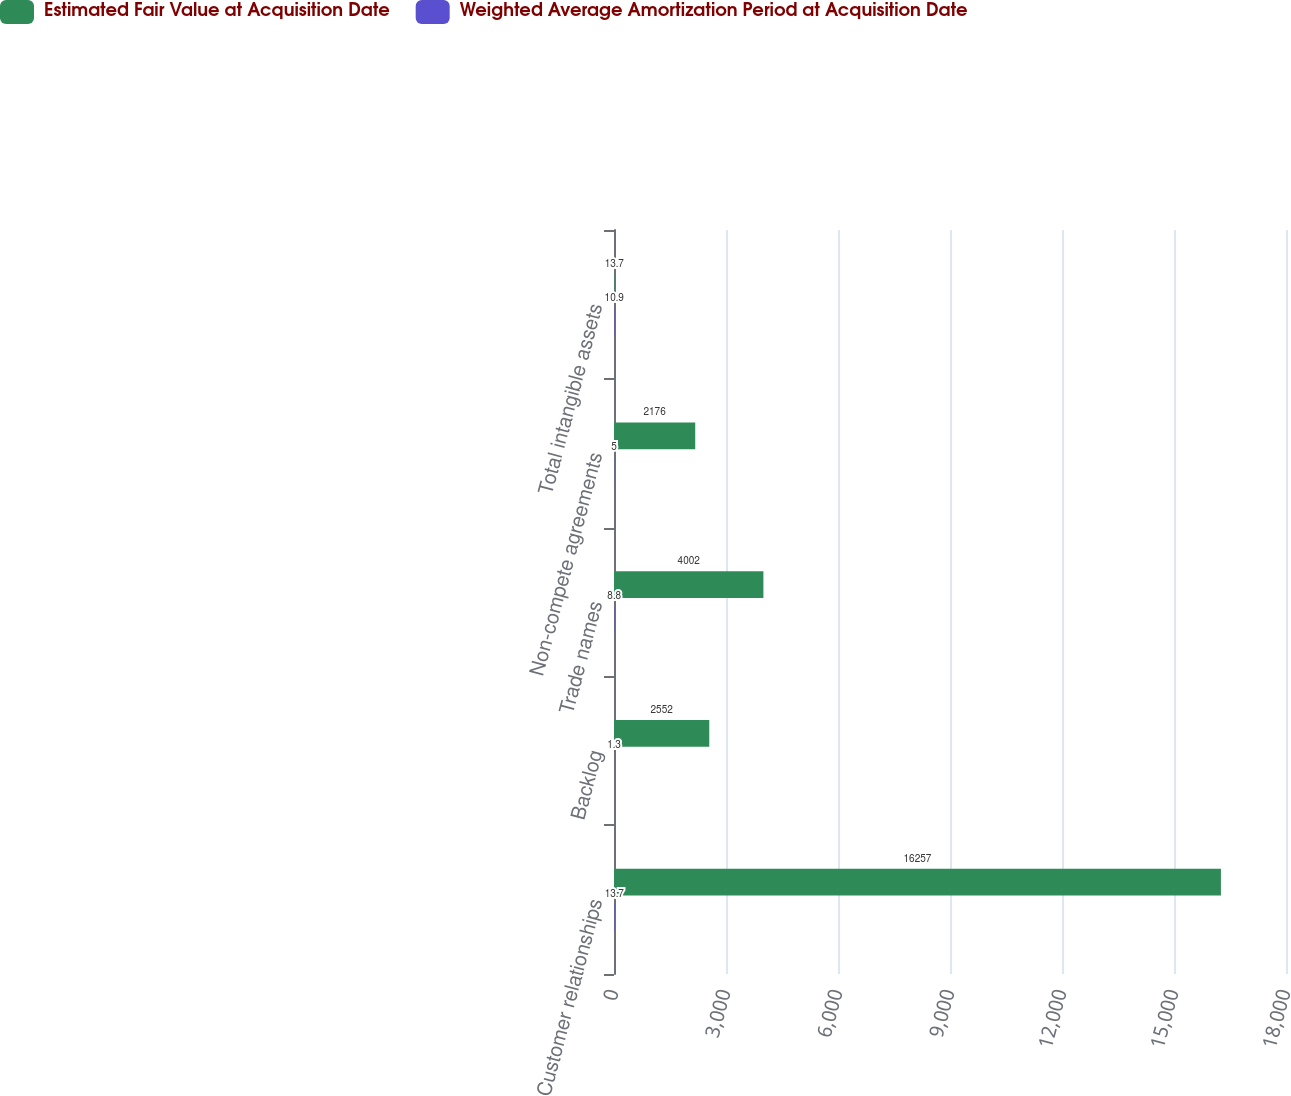<chart> <loc_0><loc_0><loc_500><loc_500><stacked_bar_chart><ecel><fcel>Customer relationships<fcel>Backlog<fcel>Trade names<fcel>Non-compete agreements<fcel>Total intangible assets<nl><fcel>Estimated Fair Value at Acquisition Date<fcel>16257<fcel>2552<fcel>4002<fcel>2176<fcel>13.7<nl><fcel>Weighted Average Amortization Period at Acquisition Date<fcel>13.7<fcel>1.3<fcel>8.8<fcel>5<fcel>10.9<nl></chart> 